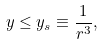Convert formula to latex. <formula><loc_0><loc_0><loc_500><loc_500>y \leq y _ { s } \equiv \frac { 1 } { r ^ { 3 } } ,</formula> 